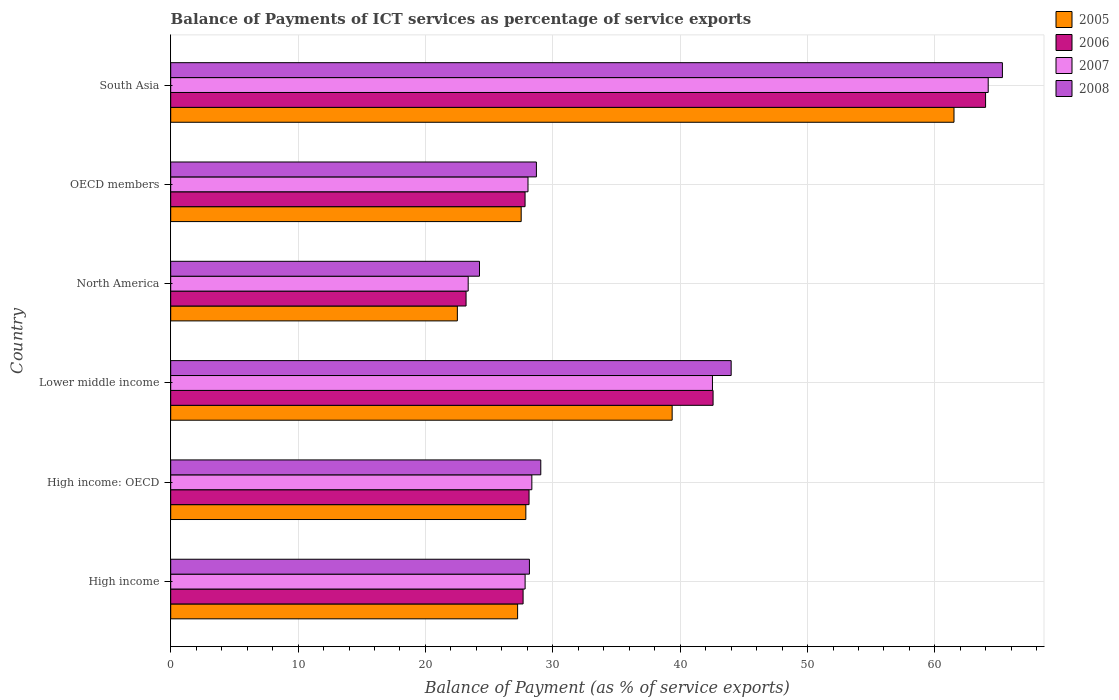Are the number of bars per tick equal to the number of legend labels?
Give a very brief answer. Yes. How many bars are there on the 5th tick from the top?
Offer a terse response. 4. What is the label of the 6th group of bars from the top?
Give a very brief answer. High income. In how many cases, is the number of bars for a given country not equal to the number of legend labels?
Provide a short and direct response. 0. What is the balance of payments of ICT services in 2005 in Lower middle income?
Your answer should be very brief. 39.37. Across all countries, what is the maximum balance of payments of ICT services in 2008?
Give a very brief answer. 65.3. Across all countries, what is the minimum balance of payments of ICT services in 2005?
Your answer should be compact. 22.51. In which country was the balance of payments of ICT services in 2006 minimum?
Provide a succinct answer. North America. What is the total balance of payments of ICT services in 2007 in the graph?
Offer a terse response. 214.31. What is the difference between the balance of payments of ICT services in 2008 in High income and that in South Asia?
Make the answer very short. -37.13. What is the difference between the balance of payments of ICT services in 2008 in South Asia and the balance of payments of ICT services in 2007 in High income?
Keep it short and to the point. 37.47. What is the average balance of payments of ICT services in 2005 per country?
Ensure brevity in your answer.  34.34. What is the difference between the balance of payments of ICT services in 2006 and balance of payments of ICT services in 2007 in High income?
Your answer should be compact. -0.16. In how many countries, is the balance of payments of ICT services in 2006 greater than 4 %?
Provide a short and direct response. 6. What is the ratio of the balance of payments of ICT services in 2005 in High income: OECD to that in South Asia?
Give a very brief answer. 0.45. Is the balance of payments of ICT services in 2007 in OECD members less than that in South Asia?
Provide a short and direct response. Yes. What is the difference between the highest and the second highest balance of payments of ICT services in 2005?
Your answer should be compact. 22.13. What is the difference between the highest and the lowest balance of payments of ICT services in 2005?
Ensure brevity in your answer.  38.99. In how many countries, is the balance of payments of ICT services in 2008 greater than the average balance of payments of ICT services in 2008 taken over all countries?
Make the answer very short. 2. What does the 3rd bar from the top in South Asia represents?
Your answer should be very brief. 2006. How many bars are there?
Ensure brevity in your answer.  24. Are all the bars in the graph horizontal?
Make the answer very short. Yes. What is the difference between two consecutive major ticks on the X-axis?
Provide a short and direct response. 10. Are the values on the major ticks of X-axis written in scientific E-notation?
Provide a succinct answer. No. Does the graph contain any zero values?
Provide a short and direct response. No. Where does the legend appear in the graph?
Provide a succinct answer. Top right. How many legend labels are there?
Keep it short and to the point. 4. How are the legend labels stacked?
Offer a terse response. Vertical. What is the title of the graph?
Ensure brevity in your answer.  Balance of Payments of ICT services as percentage of service exports. What is the label or title of the X-axis?
Keep it short and to the point. Balance of Payment (as % of service exports). What is the Balance of Payment (as % of service exports) of 2005 in High income?
Offer a terse response. 27.24. What is the Balance of Payment (as % of service exports) in 2006 in High income?
Provide a short and direct response. 27.67. What is the Balance of Payment (as % of service exports) in 2007 in High income?
Provide a short and direct response. 27.83. What is the Balance of Payment (as % of service exports) of 2008 in High income?
Your answer should be compact. 28.16. What is the Balance of Payment (as % of service exports) in 2005 in High income: OECD?
Your answer should be compact. 27.88. What is the Balance of Payment (as % of service exports) of 2006 in High income: OECD?
Your response must be concise. 28.13. What is the Balance of Payment (as % of service exports) in 2007 in High income: OECD?
Your response must be concise. 28.35. What is the Balance of Payment (as % of service exports) in 2008 in High income: OECD?
Provide a short and direct response. 29.06. What is the Balance of Payment (as % of service exports) of 2005 in Lower middle income?
Your answer should be very brief. 39.37. What is the Balance of Payment (as % of service exports) of 2006 in Lower middle income?
Your answer should be compact. 42.58. What is the Balance of Payment (as % of service exports) of 2007 in Lower middle income?
Your answer should be compact. 42.53. What is the Balance of Payment (as % of service exports) in 2008 in Lower middle income?
Your answer should be very brief. 44. What is the Balance of Payment (as % of service exports) in 2005 in North America?
Provide a short and direct response. 22.51. What is the Balance of Payment (as % of service exports) of 2006 in North America?
Offer a terse response. 23.19. What is the Balance of Payment (as % of service exports) in 2007 in North America?
Make the answer very short. 23.36. What is the Balance of Payment (as % of service exports) of 2008 in North America?
Offer a very short reply. 24.24. What is the Balance of Payment (as % of service exports) in 2005 in OECD members?
Give a very brief answer. 27.52. What is the Balance of Payment (as % of service exports) of 2006 in OECD members?
Keep it short and to the point. 27.82. What is the Balance of Payment (as % of service exports) of 2007 in OECD members?
Offer a terse response. 28.05. What is the Balance of Payment (as % of service exports) in 2008 in OECD members?
Give a very brief answer. 28.71. What is the Balance of Payment (as % of service exports) in 2005 in South Asia?
Your response must be concise. 61.5. What is the Balance of Payment (as % of service exports) in 2006 in South Asia?
Make the answer very short. 63.98. What is the Balance of Payment (as % of service exports) in 2007 in South Asia?
Offer a very short reply. 64.18. What is the Balance of Payment (as % of service exports) of 2008 in South Asia?
Your answer should be very brief. 65.3. Across all countries, what is the maximum Balance of Payment (as % of service exports) of 2005?
Your answer should be compact. 61.5. Across all countries, what is the maximum Balance of Payment (as % of service exports) of 2006?
Provide a short and direct response. 63.98. Across all countries, what is the maximum Balance of Payment (as % of service exports) of 2007?
Your response must be concise. 64.18. Across all countries, what is the maximum Balance of Payment (as % of service exports) in 2008?
Make the answer very short. 65.3. Across all countries, what is the minimum Balance of Payment (as % of service exports) of 2005?
Keep it short and to the point. 22.51. Across all countries, what is the minimum Balance of Payment (as % of service exports) in 2006?
Provide a succinct answer. 23.19. Across all countries, what is the minimum Balance of Payment (as % of service exports) in 2007?
Provide a succinct answer. 23.36. Across all countries, what is the minimum Balance of Payment (as % of service exports) in 2008?
Ensure brevity in your answer.  24.24. What is the total Balance of Payment (as % of service exports) of 2005 in the graph?
Ensure brevity in your answer.  206.01. What is the total Balance of Payment (as % of service exports) in 2006 in the graph?
Make the answer very short. 213.37. What is the total Balance of Payment (as % of service exports) in 2007 in the graph?
Offer a terse response. 214.31. What is the total Balance of Payment (as % of service exports) in 2008 in the graph?
Your answer should be very brief. 219.48. What is the difference between the Balance of Payment (as % of service exports) of 2005 in High income and that in High income: OECD?
Make the answer very short. -0.65. What is the difference between the Balance of Payment (as % of service exports) in 2006 in High income and that in High income: OECD?
Provide a short and direct response. -0.47. What is the difference between the Balance of Payment (as % of service exports) of 2007 in High income and that in High income: OECD?
Provide a succinct answer. -0.53. What is the difference between the Balance of Payment (as % of service exports) in 2008 in High income and that in High income: OECD?
Your response must be concise. -0.89. What is the difference between the Balance of Payment (as % of service exports) of 2005 in High income and that in Lower middle income?
Give a very brief answer. -12.13. What is the difference between the Balance of Payment (as % of service exports) in 2006 in High income and that in Lower middle income?
Provide a succinct answer. -14.92. What is the difference between the Balance of Payment (as % of service exports) of 2007 in High income and that in Lower middle income?
Keep it short and to the point. -14.71. What is the difference between the Balance of Payment (as % of service exports) in 2008 in High income and that in Lower middle income?
Ensure brevity in your answer.  -15.84. What is the difference between the Balance of Payment (as % of service exports) of 2005 in High income and that in North America?
Ensure brevity in your answer.  4.73. What is the difference between the Balance of Payment (as % of service exports) in 2006 in High income and that in North America?
Ensure brevity in your answer.  4.48. What is the difference between the Balance of Payment (as % of service exports) in 2007 in High income and that in North America?
Offer a terse response. 4.47. What is the difference between the Balance of Payment (as % of service exports) in 2008 in High income and that in North America?
Your answer should be very brief. 3.92. What is the difference between the Balance of Payment (as % of service exports) of 2005 in High income and that in OECD members?
Your answer should be compact. -0.28. What is the difference between the Balance of Payment (as % of service exports) in 2006 in High income and that in OECD members?
Offer a very short reply. -0.15. What is the difference between the Balance of Payment (as % of service exports) in 2007 in High income and that in OECD members?
Offer a terse response. -0.23. What is the difference between the Balance of Payment (as % of service exports) of 2008 in High income and that in OECD members?
Give a very brief answer. -0.55. What is the difference between the Balance of Payment (as % of service exports) in 2005 in High income and that in South Asia?
Offer a very short reply. -34.26. What is the difference between the Balance of Payment (as % of service exports) of 2006 in High income and that in South Asia?
Make the answer very short. -36.31. What is the difference between the Balance of Payment (as % of service exports) of 2007 in High income and that in South Asia?
Ensure brevity in your answer.  -36.36. What is the difference between the Balance of Payment (as % of service exports) in 2008 in High income and that in South Asia?
Ensure brevity in your answer.  -37.13. What is the difference between the Balance of Payment (as % of service exports) of 2005 in High income: OECD and that in Lower middle income?
Your answer should be compact. -11.49. What is the difference between the Balance of Payment (as % of service exports) in 2006 in High income: OECD and that in Lower middle income?
Give a very brief answer. -14.45. What is the difference between the Balance of Payment (as % of service exports) in 2007 in High income: OECD and that in Lower middle income?
Your answer should be compact. -14.18. What is the difference between the Balance of Payment (as % of service exports) of 2008 in High income: OECD and that in Lower middle income?
Provide a short and direct response. -14.95. What is the difference between the Balance of Payment (as % of service exports) of 2005 in High income: OECD and that in North America?
Provide a succinct answer. 5.38. What is the difference between the Balance of Payment (as % of service exports) of 2006 in High income: OECD and that in North America?
Ensure brevity in your answer.  4.95. What is the difference between the Balance of Payment (as % of service exports) of 2007 in High income: OECD and that in North America?
Provide a succinct answer. 5. What is the difference between the Balance of Payment (as % of service exports) of 2008 in High income: OECD and that in North America?
Keep it short and to the point. 4.81. What is the difference between the Balance of Payment (as % of service exports) in 2005 in High income: OECD and that in OECD members?
Your answer should be compact. 0.37. What is the difference between the Balance of Payment (as % of service exports) of 2006 in High income: OECD and that in OECD members?
Offer a very short reply. 0.31. What is the difference between the Balance of Payment (as % of service exports) of 2007 in High income: OECD and that in OECD members?
Your answer should be compact. 0.3. What is the difference between the Balance of Payment (as % of service exports) in 2008 in High income: OECD and that in OECD members?
Ensure brevity in your answer.  0.34. What is the difference between the Balance of Payment (as % of service exports) of 2005 in High income: OECD and that in South Asia?
Offer a very short reply. -33.62. What is the difference between the Balance of Payment (as % of service exports) in 2006 in High income: OECD and that in South Asia?
Ensure brevity in your answer.  -35.84. What is the difference between the Balance of Payment (as % of service exports) of 2007 in High income: OECD and that in South Asia?
Your answer should be very brief. -35.83. What is the difference between the Balance of Payment (as % of service exports) in 2008 in High income: OECD and that in South Asia?
Provide a short and direct response. -36.24. What is the difference between the Balance of Payment (as % of service exports) of 2005 in Lower middle income and that in North America?
Ensure brevity in your answer.  16.86. What is the difference between the Balance of Payment (as % of service exports) in 2006 in Lower middle income and that in North America?
Your response must be concise. 19.39. What is the difference between the Balance of Payment (as % of service exports) in 2007 in Lower middle income and that in North America?
Keep it short and to the point. 19.18. What is the difference between the Balance of Payment (as % of service exports) in 2008 in Lower middle income and that in North America?
Your answer should be very brief. 19.76. What is the difference between the Balance of Payment (as % of service exports) of 2005 in Lower middle income and that in OECD members?
Keep it short and to the point. 11.85. What is the difference between the Balance of Payment (as % of service exports) of 2006 in Lower middle income and that in OECD members?
Give a very brief answer. 14.76. What is the difference between the Balance of Payment (as % of service exports) in 2007 in Lower middle income and that in OECD members?
Offer a terse response. 14.48. What is the difference between the Balance of Payment (as % of service exports) of 2008 in Lower middle income and that in OECD members?
Offer a very short reply. 15.29. What is the difference between the Balance of Payment (as % of service exports) of 2005 in Lower middle income and that in South Asia?
Offer a terse response. -22.13. What is the difference between the Balance of Payment (as % of service exports) in 2006 in Lower middle income and that in South Asia?
Your answer should be compact. -21.39. What is the difference between the Balance of Payment (as % of service exports) in 2007 in Lower middle income and that in South Asia?
Give a very brief answer. -21.65. What is the difference between the Balance of Payment (as % of service exports) in 2008 in Lower middle income and that in South Asia?
Ensure brevity in your answer.  -21.29. What is the difference between the Balance of Payment (as % of service exports) of 2005 in North America and that in OECD members?
Offer a very short reply. -5.01. What is the difference between the Balance of Payment (as % of service exports) in 2006 in North America and that in OECD members?
Your answer should be very brief. -4.63. What is the difference between the Balance of Payment (as % of service exports) in 2007 in North America and that in OECD members?
Ensure brevity in your answer.  -4.7. What is the difference between the Balance of Payment (as % of service exports) in 2008 in North America and that in OECD members?
Your answer should be very brief. -4.47. What is the difference between the Balance of Payment (as % of service exports) of 2005 in North America and that in South Asia?
Give a very brief answer. -38.99. What is the difference between the Balance of Payment (as % of service exports) in 2006 in North America and that in South Asia?
Offer a terse response. -40.79. What is the difference between the Balance of Payment (as % of service exports) in 2007 in North America and that in South Asia?
Ensure brevity in your answer.  -40.83. What is the difference between the Balance of Payment (as % of service exports) in 2008 in North America and that in South Asia?
Provide a succinct answer. -41.06. What is the difference between the Balance of Payment (as % of service exports) in 2005 in OECD members and that in South Asia?
Offer a terse response. -33.98. What is the difference between the Balance of Payment (as % of service exports) of 2006 in OECD members and that in South Asia?
Your response must be concise. -36.16. What is the difference between the Balance of Payment (as % of service exports) of 2007 in OECD members and that in South Asia?
Give a very brief answer. -36.13. What is the difference between the Balance of Payment (as % of service exports) of 2008 in OECD members and that in South Asia?
Provide a short and direct response. -36.59. What is the difference between the Balance of Payment (as % of service exports) in 2005 in High income and the Balance of Payment (as % of service exports) in 2006 in High income: OECD?
Provide a succinct answer. -0.9. What is the difference between the Balance of Payment (as % of service exports) in 2005 in High income and the Balance of Payment (as % of service exports) in 2007 in High income: OECD?
Provide a succinct answer. -1.12. What is the difference between the Balance of Payment (as % of service exports) in 2005 in High income and the Balance of Payment (as % of service exports) in 2008 in High income: OECD?
Make the answer very short. -1.82. What is the difference between the Balance of Payment (as % of service exports) of 2006 in High income and the Balance of Payment (as % of service exports) of 2007 in High income: OECD?
Your answer should be compact. -0.69. What is the difference between the Balance of Payment (as % of service exports) in 2006 in High income and the Balance of Payment (as % of service exports) in 2008 in High income: OECD?
Provide a short and direct response. -1.39. What is the difference between the Balance of Payment (as % of service exports) of 2007 in High income and the Balance of Payment (as % of service exports) of 2008 in High income: OECD?
Provide a succinct answer. -1.23. What is the difference between the Balance of Payment (as % of service exports) in 2005 in High income and the Balance of Payment (as % of service exports) in 2006 in Lower middle income?
Make the answer very short. -15.35. What is the difference between the Balance of Payment (as % of service exports) of 2005 in High income and the Balance of Payment (as % of service exports) of 2007 in Lower middle income?
Provide a short and direct response. -15.3. What is the difference between the Balance of Payment (as % of service exports) in 2005 in High income and the Balance of Payment (as % of service exports) in 2008 in Lower middle income?
Make the answer very short. -16.77. What is the difference between the Balance of Payment (as % of service exports) of 2006 in High income and the Balance of Payment (as % of service exports) of 2007 in Lower middle income?
Keep it short and to the point. -14.87. What is the difference between the Balance of Payment (as % of service exports) of 2006 in High income and the Balance of Payment (as % of service exports) of 2008 in Lower middle income?
Make the answer very short. -16.34. What is the difference between the Balance of Payment (as % of service exports) of 2007 in High income and the Balance of Payment (as % of service exports) of 2008 in Lower middle income?
Offer a very short reply. -16.18. What is the difference between the Balance of Payment (as % of service exports) in 2005 in High income and the Balance of Payment (as % of service exports) in 2006 in North America?
Offer a terse response. 4.05. What is the difference between the Balance of Payment (as % of service exports) in 2005 in High income and the Balance of Payment (as % of service exports) in 2007 in North America?
Offer a terse response. 3.88. What is the difference between the Balance of Payment (as % of service exports) of 2005 in High income and the Balance of Payment (as % of service exports) of 2008 in North America?
Make the answer very short. 2.99. What is the difference between the Balance of Payment (as % of service exports) of 2006 in High income and the Balance of Payment (as % of service exports) of 2007 in North America?
Make the answer very short. 4.31. What is the difference between the Balance of Payment (as % of service exports) in 2006 in High income and the Balance of Payment (as % of service exports) in 2008 in North America?
Provide a succinct answer. 3.42. What is the difference between the Balance of Payment (as % of service exports) in 2007 in High income and the Balance of Payment (as % of service exports) in 2008 in North America?
Your response must be concise. 3.58. What is the difference between the Balance of Payment (as % of service exports) in 2005 in High income and the Balance of Payment (as % of service exports) in 2006 in OECD members?
Provide a short and direct response. -0.59. What is the difference between the Balance of Payment (as % of service exports) of 2005 in High income and the Balance of Payment (as % of service exports) of 2007 in OECD members?
Offer a very short reply. -0.82. What is the difference between the Balance of Payment (as % of service exports) of 2005 in High income and the Balance of Payment (as % of service exports) of 2008 in OECD members?
Your response must be concise. -1.48. What is the difference between the Balance of Payment (as % of service exports) of 2006 in High income and the Balance of Payment (as % of service exports) of 2007 in OECD members?
Provide a short and direct response. -0.39. What is the difference between the Balance of Payment (as % of service exports) of 2006 in High income and the Balance of Payment (as % of service exports) of 2008 in OECD members?
Your answer should be compact. -1.05. What is the difference between the Balance of Payment (as % of service exports) of 2007 in High income and the Balance of Payment (as % of service exports) of 2008 in OECD members?
Offer a very short reply. -0.89. What is the difference between the Balance of Payment (as % of service exports) of 2005 in High income and the Balance of Payment (as % of service exports) of 2006 in South Asia?
Offer a very short reply. -36.74. What is the difference between the Balance of Payment (as % of service exports) of 2005 in High income and the Balance of Payment (as % of service exports) of 2007 in South Asia?
Give a very brief answer. -36.95. What is the difference between the Balance of Payment (as % of service exports) in 2005 in High income and the Balance of Payment (as % of service exports) in 2008 in South Asia?
Your answer should be very brief. -38.06. What is the difference between the Balance of Payment (as % of service exports) in 2006 in High income and the Balance of Payment (as % of service exports) in 2007 in South Asia?
Provide a succinct answer. -36.52. What is the difference between the Balance of Payment (as % of service exports) in 2006 in High income and the Balance of Payment (as % of service exports) in 2008 in South Asia?
Your answer should be compact. -37.63. What is the difference between the Balance of Payment (as % of service exports) in 2007 in High income and the Balance of Payment (as % of service exports) in 2008 in South Asia?
Offer a very short reply. -37.47. What is the difference between the Balance of Payment (as % of service exports) in 2005 in High income: OECD and the Balance of Payment (as % of service exports) in 2006 in Lower middle income?
Your answer should be very brief. -14.7. What is the difference between the Balance of Payment (as % of service exports) of 2005 in High income: OECD and the Balance of Payment (as % of service exports) of 2007 in Lower middle income?
Provide a short and direct response. -14.65. What is the difference between the Balance of Payment (as % of service exports) in 2005 in High income: OECD and the Balance of Payment (as % of service exports) in 2008 in Lower middle income?
Ensure brevity in your answer.  -16.12. What is the difference between the Balance of Payment (as % of service exports) in 2006 in High income: OECD and the Balance of Payment (as % of service exports) in 2007 in Lower middle income?
Your answer should be very brief. -14.4. What is the difference between the Balance of Payment (as % of service exports) of 2006 in High income: OECD and the Balance of Payment (as % of service exports) of 2008 in Lower middle income?
Give a very brief answer. -15.87. What is the difference between the Balance of Payment (as % of service exports) in 2007 in High income: OECD and the Balance of Payment (as % of service exports) in 2008 in Lower middle income?
Your answer should be very brief. -15.65. What is the difference between the Balance of Payment (as % of service exports) in 2005 in High income: OECD and the Balance of Payment (as % of service exports) in 2006 in North America?
Your answer should be very brief. 4.69. What is the difference between the Balance of Payment (as % of service exports) of 2005 in High income: OECD and the Balance of Payment (as % of service exports) of 2007 in North America?
Keep it short and to the point. 4.53. What is the difference between the Balance of Payment (as % of service exports) of 2005 in High income: OECD and the Balance of Payment (as % of service exports) of 2008 in North America?
Provide a succinct answer. 3.64. What is the difference between the Balance of Payment (as % of service exports) in 2006 in High income: OECD and the Balance of Payment (as % of service exports) in 2007 in North America?
Ensure brevity in your answer.  4.78. What is the difference between the Balance of Payment (as % of service exports) of 2006 in High income: OECD and the Balance of Payment (as % of service exports) of 2008 in North America?
Provide a succinct answer. 3.89. What is the difference between the Balance of Payment (as % of service exports) of 2007 in High income: OECD and the Balance of Payment (as % of service exports) of 2008 in North America?
Make the answer very short. 4.11. What is the difference between the Balance of Payment (as % of service exports) in 2005 in High income: OECD and the Balance of Payment (as % of service exports) in 2006 in OECD members?
Make the answer very short. 0.06. What is the difference between the Balance of Payment (as % of service exports) of 2005 in High income: OECD and the Balance of Payment (as % of service exports) of 2007 in OECD members?
Ensure brevity in your answer.  -0.17. What is the difference between the Balance of Payment (as % of service exports) of 2005 in High income: OECD and the Balance of Payment (as % of service exports) of 2008 in OECD members?
Give a very brief answer. -0.83. What is the difference between the Balance of Payment (as % of service exports) in 2006 in High income: OECD and the Balance of Payment (as % of service exports) in 2007 in OECD members?
Offer a very short reply. 0.08. What is the difference between the Balance of Payment (as % of service exports) of 2006 in High income: OECD and the Balance of Payment (as % of service exports) of 2008 in OECD members?
Provide a succinct answer. -0.58. What is the difference between the Balance of Payment (as % of service exports) of 2007 in High income: OECD and the Balance of Payment (as % of service exports) of 2008 in OECD members?
Offer a very short reply. -0.36. What is the difference between the Balance of Payment (as % of service exports) in 2005 in High income: OECD and the Balance of Payment (as % of service exports) in 2006 in South Asia?
Provide a succinct answer. -36.09. What is the difference between the Balance of Payment (as % of service exports) of 2005 in High income: OECD and the Balance of Payment (as % of service exports) of 2007 in South Asia?
Your response must be concise. -36.3. What is the difference between the Balance of Payment (as % of service exports) of 2005 in High income: OECD and the Balance of Payment (as % of service exports) of 2008 in South Asia?
Provide a short and direct response. -37.42. What is the difference between the Balance of Payment (as % of service exports) of 2006 in High income: OECD and the Balance of Payment (as % of service exports) of 2007 in South Asia?
Offer a terse response. -36.05. What is the difference between the Balance of Payment (as % of service exports) of 2006 in High income: OECD and the Balance of Payment (as % of service exports) of 2008 in South Asia?
Give a very brief answer. -37.16. What is the difference between the Balance of Payment (as % of service exports) in 2007 in High income: OECD and the Balance of Payment (as % of service exports) in 2008 in South Asia?
Make the answer very short. -36.94. What is the difference between the Balance of Payment (as % of service exports) in 2005 in Lower middle income and the Balance of Payment (as % of service exports) in 2006 in North America?
Keep it short and to the point. 16.18. What is the difference between the Balance of Payment (as % of service exports) in 2005 in Lower middle income and the Balance of Payment (as % of service exports) in 2007 in North America?
Provide a succinct answer. 16.01. What is the difference between the Balance of Payment (as % of service exports) of 2005 in Lower middle income and the Balance of Payment (as % of service exports) of 2008 in North America?
Your response must be concise. 15.13. What is the difference between the Balance of Payment (as % of service exports) of 2006 in Lower middle income and the Balance of Payment (as % of service exports) of 2007 in North America?
Keep it short and to the point. 19.23. What is the difference between the Balance of Payment (as % of service exports) in 2006 in Lower middle income and the Balance of Payment (as % of service exports) in 2008 in North America?
Keep it short and to the point. 18.34. What is the difference between the Balance of Payment (as % of service exports) in 2007 in Lower middle income and the Balance of Payment (as % of service exports) in 2008 in North America?
Keep it short and to the point. 18.29. What is the difference between the Balance of Payment (as % of service exports) of 2005 in Lower middle income and the Balance of Payment (as % of service exports) of 2006 in OECD members?
Give a very brief answer. 11.55. What is the difference between the Balance of Payment (as % of service exports) of 2005 in Lower middle income and the Balance of Payment (as % of service exports) of 2007 in OECD members?
Provide a succinct answer. 11.32. What is the difference between the Balance of Payment (as % of service exports) in 2005 in Lower middle income and the Balance of Payment (as % of service exports) in 2008 in OECD members?
Your answer should be compact. 10.66. What is the difference between the Balance of Payment (as % of service exports) of 2006 in Lower middle income and the Balance of Payment (as % of service exports) of 2007 in OECD members?
Offer a very short reply. 14.53. What is the difference between the Balance of Payment (as % of service exports) in 2006 in Lower middle income and the Balance of Payment (as % of service exports) in 2008 in OECD members?
Make the answer very short. 13.87. What is the difference between the Balance of Payment (as % of service exports) in 2007 in Lower middle income and the Balance of Payment (as % of service exports) in 2008 in OECD members?
Offer a very short reply. 13.82. What is the difference between the Balance of Payment (as % of service exports) of 2005 in Lower middle income and the Balance of Payment (as % of service exports) of 2006 in South Asia?
Provide a short and direct response. -24.61. What is the difference between the Balance of Payment (as % of service exports) of 2005 in Lower middle income and the Balance of Payment (as % of service exports) of 2007 in South Asia?
Provide a succinct answer. -24.81. What is the difference between the Balance of Payment (as % of service exports) of 2005 in Lower middle income and the Balance of Payment (as % of service exports) of 2008 in South Asia?
Your response must be concise. -25.93. What is the difference between the Balance of Payment (as % of service exports) in 2006 in Lower middle income and the Balance of Payment (as % of service exports) in 2007 in South Asia?
Provide a short and direct response. -21.6. What is the difference between the Balance of Payment (as % of service exports) in 2006 in Lower middle income and the Balance of Payment (as % of service exports) in 2008 in South Asia?
Provide a short and direct response. -22.72. What is the difference between the Balance of Payment (as % of service exports) in 2007 in Lower middle income and the Balance of Payment (as % of service exports) in 2008 in South Asia?
Keep it short and to the point. -22.76. What is the difference between the Balance of Payment (as % of service exports) in 2005 in North America and the Balance of Payment (as % of service exports) in 2006 in OECD members?
Your response must be concise. -5.32. What is the difference between the Balance of Payment (as % of service exports) in 2005 in North America and the Balance of Payment (as % of service exports) in 2007 in OECD members?
Provide a short and direct response. -5.55. What is the difference between the Balance of Payment (as % of service exports) of 2005 in North America and the Balance of Payment (as % of service exports) of 2008 in OECD members?
Your response must be concise. -6.21. What is the difference between the Balance of Payment (as % of service exports) in 2006 in North America and the Balance of Payment (as % of service exports) in 2007 in OECD members?
Your response must be concise. -4.86. What is the difference between the Balance of Payment (as % of service exports) of 2006 in North America and the Balance of Payment (as % of service exports) of 2008 in OECD members?
Provide a short and direct response. -5.52. What is the difference between the Balance of Payment (as % of service exports) of 2007 in North America and the Balance of Payment (as % of service exports) of 2008 in OECD members?
Make the answer very short. -5.36. What is the difference between the Balance of Payment (as % of service exports) in 2005 in North America and the Balance of Payment (as % of service exports) in 2006 in South Asia?
Make the answer very short. -41.47. What is the difference between the Balance of Payment (as % of service exports) of 2005 in North America and the Balance of Payment (as % of service exports) of 2007 in South Asia?
Offer a terse response. -41.68. What is the difference between the Balance of Payment (as % of service exports) of 2005 in North America and the Balance of Payment (as % of service exports) of 2008 in South Asia?
Your answer should be compact. -42.79. What is the difference between the Balance of Payment (as % of service exports) in 2006 in North America and the Balance of Payment (as % of service exports) in 2007 in South Asia?
Offer a very short reply. -40.99. What is the difference between the Balance of Payment (as % of service exports) in 2006 in North America and the Balance of Payment (as % of service exports) in 2008 in South Asia?
Your answer should be compact. -42.11. What is the difference between the Balance of Payment (as % of service exports) of 2007 in North America and the Balance of Payment (as % of service exports) of 2008 in South Asia?
Provide a succinct answer. -41.94. What is the difference between the Balance of Payment (as % of service exports) in 2005 in OECD members and the Balance of Payment (as % of service exports) in 2006 in South Asia?
Ensure brevity in your answer.  -36.46. What is the difference between the Balance of Payment (as % of service exports) in 2005 in OECD members and the Balance of Payment (as % of service exports) in 2007 in South Asia?
Provide a short and direct response. -36.67. What is the difference between the Balance of Payment (as % of service exports) of 2005 in OECD members and the Balance of Payment (as % of service exports) of 2008 in South Asia?
Provide a short and direct response. -37.78. What is the difference between the Balance of Payment (as % of service exports) of 2006 in OECD members and the Balance of Payment (as % of service exports) of 2007 in South Asia?
Provide a short and direct response. -36.36. What is the difference between the Balance of Payment (as % of service exports) of 2006 in OECD members and the Balance of Payment (as % of service exports) of 2008 in South Asia?
Offer a very short reply. -37.48. What is the difference between the Balance of Payment (as % of service exports) of 2007 in OECD members and the Balance of Payment (as % of service exports) of 2008 in South Asia?
Provide a succinct answer. -37.25. What is the average Balance of Payment (as % of service exports) of 2005 per country?
Your answer should be compact. 34.34. What is the average Balance of Payment (as % of service exports) of 2006 per country?
Your answer should be compact. 35.56. What is the average Balance of Payment (as % of service exports) of 2007 per country?
Provide a short and direct response. 35.72. What is the average Balance of Payment (as % of service exports) of 2008 per country?
Provide a succinct answer. 36.58. What is the difference between the Balance of Payment (as % of service exports) of 2005 and Balance of Payment (as % of service exports) of 2006 in High income?
Give a very brief answer. -0.43. What is the difference between the Balance of Payment (as % of service exports) of 2005 and Balance of Payment (as % of service exports) of 2007 in High income?
Keep it short and to the point. -0.59. What is the difference between the Balance of Payment (as % of service exports) of 2005 and Balance of Payment (as % of service exports) of 2008 in High income?
Offer a terse response. -0.93. What is the difference between the Balance of Payment (as % of service exports) of 2006 and Balance of Payment (as % of service exports) of 2007 in High income?
Offer a very short reply. -0.16. What is the difference between the Balance of Payment (as % of service exports) of 2006 and Balance of Payment (as % of service exports) of 2008 in High income?
Offer a terse response. -0.5. What is the difference between the Balance of Payment (as % of service exports) in 2007 and Balance of Payment (as % of service exports) in 2008 in High income?
Your answer should be compact. -0.34. What is the difference between the Balance of Payment (as % of service exports) of 2005 and Balance of Payment (as % of service exports) of 2006 in High income: OECD?
Provide a short and direct response. -0.25. What is the difference between the Balance of Payment (as % of service exports) of 2005 and Balance of Payment (as % of service exports) of 2007 in High income: OECD?
Your answer should be very brief. -0.47. What is the difference between the Balance of Payment (as % of service exports) of 2005 and Balance of Payment (as % of service exports) of 2008 in High income: OECD?
Your answer should be compact. -1.17. What is the difference between the Balance of Payment (as % of service exports) in 2006 and Balance of Payment (as % of service exports) in 2007 in High income: OECD?
Ensure brevity in your answer.  -0.22. What is the difference between the Balance of Payment (as % of service exports) of 2006 and Balance of Payment (as % of service exports) of 2008 in High income: OECD?
Your answer should be very brief. -0.92. What is the difference between the Balance of Payment (as % of service exports) of 2007 and Balance of Payment (as % of service exports) of 2008 in High income: OECD?
Provide a succinct answer. -0.7. What is the difference between the Balance of Payment (as % of service exports) in 2005 and Balance of Payment (as % of service exports) in 2006 in Lower middle income?
Ensure brevity in your answer.  -3.21. What is the difference between the Balance of Payment (as % of service exports) in 2005 and Balance of Payment (as % of service exports) in 2007 in Lower middle income?
Your response must be concise. -3.16. What is the difference between the Balance of Payment (as % of service exports) in 2005 and Balance of Payment (as % of service exports) in 2008 in Lower middle income?
Give a very brief answer. -4.63. What is the difference between the Balance of Payment (as % of service exports) in 2006 and Balance of Payment (as % of service exports) in 2007 in Lower middle income?
Offer a terse response. 0.05. What is the difference between the Balance of Payment (as % of service exports) of 2006 and Balance of Payment (as % of service exports) of 2008 in Lower middle income?
Your answer should be compact. -1.42. What is the difference between the Balance of Payment (as % of service exports) in 2007 and Balance of Payment (as % of service exports) in 2008 in Lower middle income?
Offer a very short reply. -1.47. What is the difference between the Balance of Payment (as % of service exports) in 2005 and Balance of Payment (as % of service exports) in 2006 in North America?
Give a very brief answer. -0.68. What is the difference between the Balance of Payment (as % of service exports) in 2005 and Balance of Payment (as % of service exports) in 2007 in North America?
Ensure brevity in your answer.  -0.85. What is the difference between the Balance of Payment (as % of service exports) of 2005 and Balance of Payment (as % of service exports) of 2008 in North America?
Your answer should be compact. -1.74. What is the difference between the Balance of Payment (as % of service exports) of 2006 and Balance of Payment (as % of service exports) of 2007 in North America?
Provide a short and direct response. -0.17. What is the difference between the Balance of Payment (as % of service exports) of 2006 and Balance of Payment (as % of service exports) of 2008 in North America?
Ensure brevity in your answer.  -1.05. What is the difference between the Balance of Payment (as % of service exports) of 2007 and Balance of Payment (as % of service exports) of 2008 in North America?
Keep it short and to the point. -0.89. What is the difference between the Balance of Payment (as % of service exports) in 2005 and Balance of Payment (as % of service exports) in 2006 in OECD members?
Offer a terse response. -0.3. What is the difference between the Balance of Payment (as % of service exports) in 2005 and Balance of Payment (as % of service exports) in 2007 in OECD members?
Your answer should be compact. -0.54. What is the difference between the Balance of Payment (as % of service exports) of 2005 and Balance of Payment (as % of service exports) of 2008 in OECD members?
Your answer should be very brief. -1.2. What is the difference between the Balance of Payment (as % of service exports) in 2006 and Balance of Payment (as % of service exports) in 2007 in OECD members?
Your answer should be very brief. -0.23. What is the difference between the Balance of Payment (as % of service exports) in 2006 and Balance of Payment (as % of service exports) in 2008 in OECD members?
Offer a very short reply. -0.89. What is the difference between the Balance of Payment (as % of service exports) in 2007 and Balance of Payment (as % of service exports) in 2008 in OECD members?
Make the answer very short. -0.66. What is the difference between the Balance of Payment (as % of service exports) of 2005 and Balance of Payment (as % of service exports) of 2006 in South Asia?
Offer a very short reply. -2.48. What is the difference between the Balance of Payment (as % of service exports) of 2005 and Balance of Payment (as % of service exports) of 2007 in South Asia?
Provide a succinct answer. -2.69. What is the difference between the Balance of Payment (as % of service exports) of 2005 and Balance of Payment (as % of service exports) of 2008 in South Asia?
Your answer should be very brief. -3.8. What is the difference between the Balance of Payment (as % of service exports) of 2006 and Balance of Payment (as % of service exports) of 2007 in South Asia?
Offer a very short reply. -0.21. What is the difference between the Balance of Payment (as % of service exports) of 2006 and Balance of Payment (as % of service exports) of 2008 in South Asia?
Offer a terse response. -1.32. What is the difference between the Balance of Payment (as % of service exports) of 2007 and Balance of Payment (as % of service exports) of 2008 in South Asia?
Offer a very short reply. -1.11. What is the ratio of the Balance of Payment (as % of service exports) in 2005 in High income to that in High income: OECD?
Offer a terse response. 0.98. What is the ratio of the Balance of Payment (as % of service exports) of 2006 in High income to that in High income: OECD?
Provide a succinct answer. 0.98. What is the ratio of the Balance of Payment (as % of service exports) of 2007 in High income to that in High income: OECD?
Provide a short and direct response. 0.98. What is the ratio of the Balance of Payment (as % of service exports) in 2008 in High income to that in High income: OECD?
Your answer should be compact. 0.97. What is the ratio of the Balance of Payment (as % of service exports) in 2005 in High income to that in Lower middle income?
Provide a succinct answer. 0.69. What is the ratio of the Balance of Payment (as % of service exports) in 2006 in High income to that in Lower middle income?
Provide a short and direct response. 0.65. What is the ratio of the Balance of Payment (as % of service exports) in 2007 in High income to that in Lower middle income?
Offer a very short reply. 0.65. What is the ratio of the Balance of Payment (as % of service exports) of 2008 in High income to that in Lower middle income?
Keep it short and to the point. 0.64. What is the ratio of the Balance of Payment (as % of service exports) of 2005 in High income to that in North America?
Provide a short and direct response. 1.21. What is the ratio of the Balance of Payment (as % of service exports) in 2006 in High income to that in North America?
Your response must be concise. 1.19. What is the ratio of the Balance of Payment (as % of service exports) in 2007 in High income to that in North America?
Make the answer very short. 1.19. What is the ratio of the Balance of Payment (as % of service exports) in 2008 in High income to that in North America?
Provide a short and direct response. 1.16. What is the ratio of the Balance of Payment (as % of service exports) of 2005 in High income to that in OECD members?
Ensure brevity in your answer.  0.99. What is the ratio of the Balance of Payment (as % of service exports) of 2007 in High income to that in OECD members?
Offer a terse response. 0.99. What is the ratio of the Balance of Payment (as % of service exports) in 2008 in High income to that in OECD members?
Your response must be concise. 0.98. What is the ratio of the Balance of Payment (as % of service exports) of 2005 in High income to that in South Asia?
Offer a very short reply. 0.44. What is the ratio of the Balance of Payment (as % of service exports) in 2006 in High income to that in South Asia?
Give a very brief answer. 0.43. What is the ratio of the Balance of Payment (as % of service exports) in 2007 in High income to that in South Asia?
Offer a very short reply. 0.43. What is the ratio of the Balance of Payment (as % of service exports) of 2008 in High income to that in South Asia?
Your answer should be very brief. 0.43. What is the ratio of the Balance of Payment (as % of service exports) in 2005 in High income: OECD to that in Lower middle income?
Ensure brevity in your answer.  0.71. What is the ratio of the Balance of Payment (as % of service exports) in 2006 in High income: OECD to that in Lower middle income?
Offer a terse response. 0.66. What is the ratio of the Balance of Payment (as % of service exports) in 2007 in High income: OECD to that in Lower middle income?
Your answer should be very brief. 0.67. What is the ratio of the Balance of Payment (as % of service exports) of 2008 in High income: OECD to that in Lower middle income?
Your response must be concise. 0.66. What is the ratio of the Balance of Payment (as % of service exports) of 2005 in High income: OECD to that in North America?
Provide a succinct answer. 1.24. What is the ratio of the Balance of Payment (as % of service exports) in 2006 in High income: OECD to that in North America?
Make the answer very short. 1.21. What is the ratio of the Balance of Payment (as % of service exports) of 2007 in High income: OECD to that in North America?
Offer a terse response. 1.21. What is the ratio of the Balance of Payment (as % of service exports) in 2008 in High income: OECD to that in North America?
Give a very brief answer. 1.2. What is the ratio of the Balance of Payment (as % of service exports) in 2005 in High income: OECD to that in OECD members?
Provide a succinct answer. 1.01. What is the ratio of the Balance of Payment (as % of service exports) of 2006 in High income: OECD to that in OECD members?
Give a very brief answer. 1.01. What is the ratio of the Balance of Payment (as % of service exports) of 2007 in High income: OECD to that in OECD members?
Provide a short and direct response. 1.01. What is the ratio of the Balance of Payment (as % of service exports) in 2008 in High income: OECD to that in OECD members?
Keep it short and to the point. 1.01. What is the ratio of the Balance of Payment (as % of service exports) of 2005 in High income: OECD to that in South Asia?
Keep it short and to the point. 0.45. What is the ratio of the Balance of Payment (as % of service exports) in 2006 in High income: OECD to that in South Asia?
Make the answer very short. 0.44. What is the ratio of the Balance of Payment (as % of service exports) of 2007 in High income: OECD to that in South Asia?
Provide a succinct answer. 0.44. What is the ratio of the Balance of Payment (as % of service exports) of 2008 in High income: OECD to that in South Asia?
Provide a short and direct response. 0.45. What is the ratio of the Balance of Payment (as % of service exports) of 2005 in Lower middle income to that in North America?
Make the answer very short. 1.75. What is the ratio of the Balance of Payment (as % of service exports) in 2006 in Lower middle income to that in North America?
Your answer should be very brief. 1.84. What is the ratio of the Balance of Payment (as % of service exports) of 2007 in Lower middle income to that in North America?
Your answer should be compact. 1.82. What is the ratio of the Balance of Payment (as % of service exports) of 2008 in Lower middle income to that in North America?
Make the answer very short. 1.82. What is the ratio of the Balance of Payment (as % of service exports) of 2005 in Lower middle income to that in OECD members?
Your answer should be compact. 1.43. What is the ratio of the Balance of Payment (as % of service exports) in 2006 in Lower middle income to that in OECD members?
Ensure brevity in your answer.  1.53. What is the ratio of the Balance of Payment (as % of service exports) in 2007 in Lower middle income to that in OECD members?
Provide a succinct answer. 1.52. What is the ratio of the Balance of Payment (as % of service exports) in 2008 in Lower middle income to that in OECD members?
Offer a very short reply. 1.53. What is the ratio of the Balance of Payment (as % of service exports) of 2005 in Lower middle income to that in South Asia?
Make the answer very short. 0.64. What is the ratio of the Balance of Payment (as % of service exports) of 2006 in Lower middle income to that in South Asia?
Make the answer very short. 0.67. What is the ratio of the Balance of Payment (as % of service exports) of 2007 in Lower middle income to that in South Asia?
Ensure brevity in your answer.  0.66. What is the ratio of the Balance of Payment (as % of service exports) in 2008 in Lower middle income to that in South Asia?
Your answer should be very brief. 0.67. What is the ratio of the Balance of Payment (as % of service exports) of 2005 in North America to that in OECD members?
Provide a succinct answer. 0.82. What is the ratio of the Balance of Payment (as % of service exports) of 2006 in North America to that in OECD members?
Ensure brevity in your answer.  0.83. What is the ratio of the Balance of Payment (as % of service exports) in 2007 in North America to that in OECD members?
Provide a succinct answer. 0.83. What is the ratio of the Balance of Payment (as % of service exports) of 2008 in North America to that in OECD members?
Provide a short and direct response. 0.84. What is the ratio of the Balance of Payment (as % of service exports) in 2005 in North America to that in South Asia?
Your answer should be compact. 0.37. What is the ratio of the Balance of Payment (as % of service exports) of 2006 in North America to that in South Asia?
Your answer should be compact. 0.36. What is the ratio of the Balance of Payment (as % of service exports) of 2007 in North America to that in South Asia?
Offer a terse response. 0.36. What is the ratio of the Balance of Payment (as % of service exports) of 2008 in North America to that in South Asia?
Offer a terse response. 0.37. What is the ratio of the Balance of Payment (as % of service exports) of 2005 in OECD members to that in South Asia?
Your response must be concise. 0.45. What is the ratio of the Balance of Payment (as % of service exports) of 2006 in OECD members to that in South Asia?
Keep it short and to the point. 0.43. What is the ratio of the Balance of Payment (as % of service exports) in 2007 in OECD members to that in South Asia?
Offer a terse response. 0.44. What is the ratio of the Balance of Payment (as % of service exports) in 2008 in OECD members to that in South Asia?
Provide a short and direct response. 0.44. What is the difference between the highest and the second highest Balance of Payment (as % of service exports) of 2005?
Your response must be concise. 22.13. What is the difference between the highest and the second highest Balance of Payment (as % of service exports) of 2006?
Offer a terse response. 21.39. What is the difference between the highest and the second highest Balance of Payment (as % of service exports) in 2007?
Your answer should be very brief. 21.65. What is the difference between the highest and the second highest Balance of Payment (as % of service exports) in 2008?
Offer a very short reply. 21.29. What is the difference between the highest and the lowest Balance of Payment (as % of service exports) in 2005?
Make the answer very short. 38.99. What is the difference between the highest and the lowest Balance of Payment (as % of service exports) in 2006?
Your answer should be compact. 40.79. What is the difference between the highest and the lowest Balance of Payment (as % of service exports) in 2007?
Your answer should be compact. 40.83. What is the difference between the highest and the lowest Balance of Payment (as % of service exports) in 2008?
Ensure brevity in your answer.  41.06. 